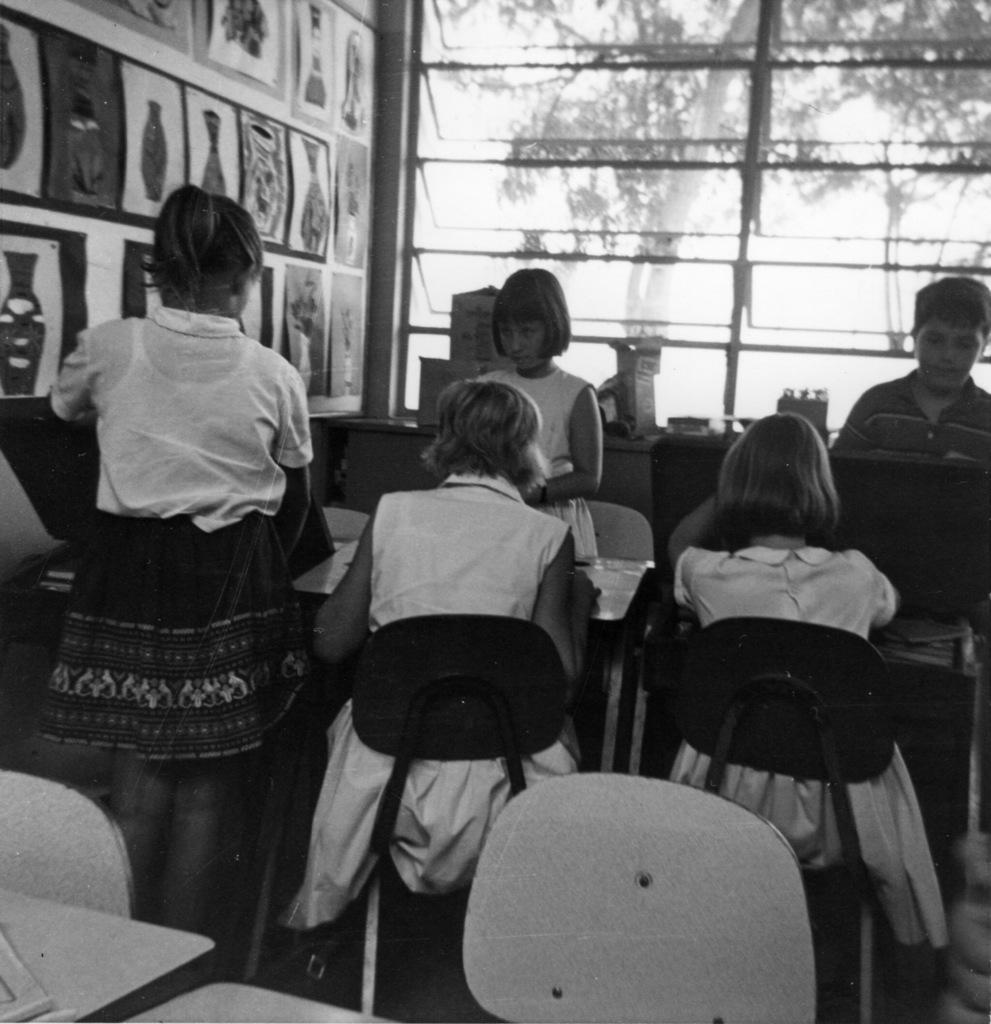Please provide a concise description of this image. In this image two persons are sitting on a chair before a table and three persons are standing. Backside there is a window in which tree is visible. At the left side there are few images on the wall. 